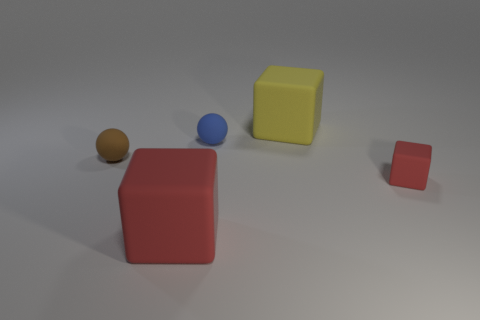There is a red matte thing that is on the right side of the ball behind the small brown matte object; what is its shape?
Your answer should be compact. Cube. Is there another big yellow metallic object that has the same shape as the large yellow thing?
Make the answer very short. No. There is a small block; is its color the same as the rubber ball that is to the right of the big red thing?
Your answer should be very brief. No. There is another block that is the same color as the tiny block; what is its size?
Your answer should be compact. Large. Is there a brown matte object that has the same size as the blue rubber ball?
Your answer should be very brief. Yes. Are the blue object and the big block that is in front of the small blue rubber ball made of the same material?
Make the answer very short. Yes. Is the number of green rubber cylinders greater than the number of large cubes?
Provide a succinct answer. No. How many cylinders are either small blue matte objects or small cyan metallic objects?
Provide a succinct answer. 0. What color is the small cube?
Make the answer very short. Red. Is the size of the rubber cube that is in front of the small block the same as the cube behind the brown thing?
Your answer should be compact. Yes. 